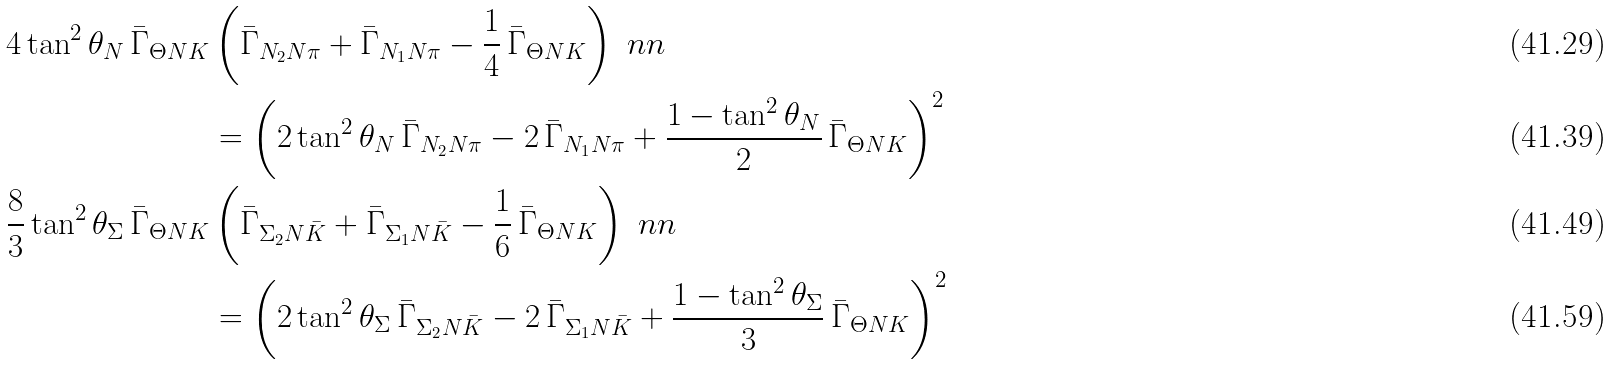<formula> <loc_0><loc_0><loc_500><loc_500>4 \tan ^ { 2 } { \theta _ { N } } \, \bar { \Gamma } _ { \Theta N K } & \left ( \bar { \Gamma } _ { N _ { 2 } N \pi } + \bar { \Gamma } _ { N _ { 1 } N \pi } - \frac { 1 } { 4 } \, \bar { \Gamma } _ { \Theta N K } \right ) \ n n \\ & = \left ( 2 \tan ^ { 2 } { \theta _ { N } } \, \bar { \Gamma } _ { N _ { 2 } N \pi } - 2 \, \bar { \Gamma } _ { N _ { 1 } N \pi } + \frac { 1 - \tan ^ { 2 } { \theta _ { N } } } { 2 } \, \bar { \Gamma } _ { \Theta N K } \right ) ^ { 2 } \\ \frac { 8 } { 3 } \tan ^ { 2 } { \theta _ { \Sigma } } \, \bar { \Gamma } _ { \Theta N K } & \left ( \bar { \Gamma } _ { \Sigma _ { 2 } N \bar { K } } + \bar { \Gamma } _ { \Sigma _ { 1 } N \bar { K } } - \frac { 1 } { 6 } \, \bar { \Gamma } _ { \Theta N K } \right ) \ n n \\ & = \left ( 2 \tan ^ { 2 } { \theta _ { \Sigma } } \, \bar { \Gamma } _ { \Sigma _ { 2 } N \bar { K } } - 2 \, \bar { \Gamma } _ { \Sigma _ { 1 } N \bar { K } } + \frac { 1 - \tan ^ { 2 } { \theta _ { \Sigma } } } { 3 } \, \bar { \Gamma } _ { \Theta N K } \right ) ^ { 2 }</formula> 